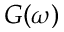<formula> <loc_0><loc_0><loc_500><loc_500>G ( \omega )</formula> 